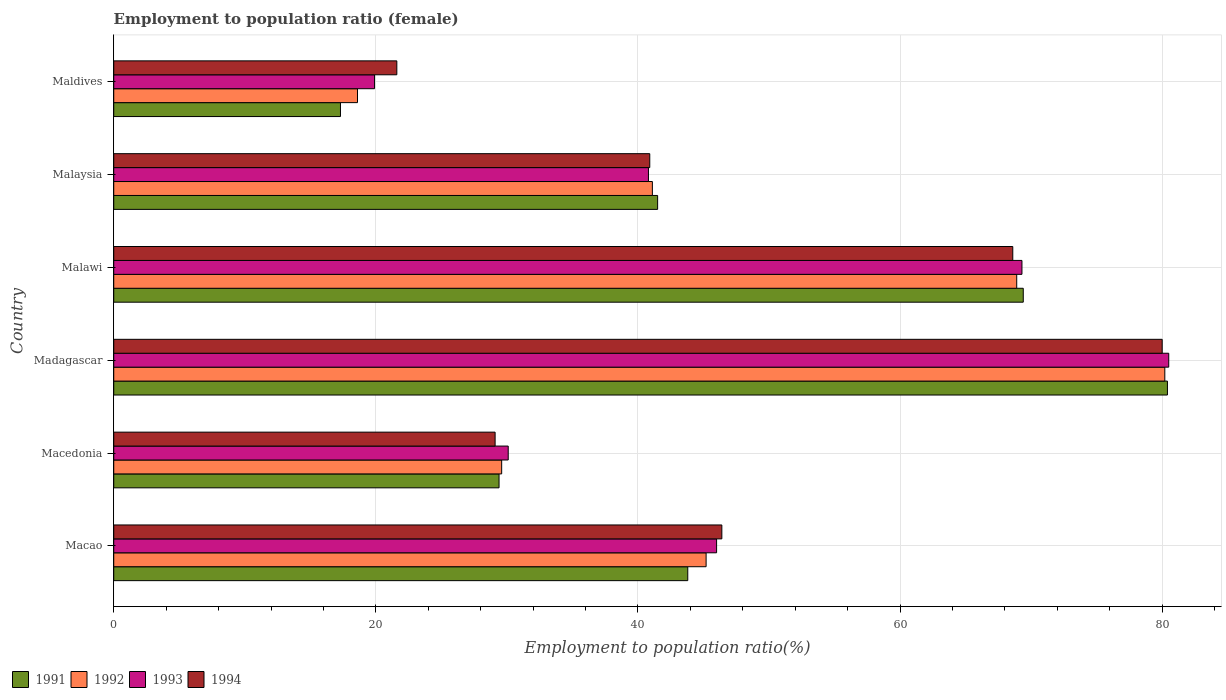How many groups of bars are there?
Your answer should be very brief. 6. Are the number of bars on each tick of the Y-axis equal?
Your answer should be compact. Yes. How many bars are there on the 2nd tick from the top?
Your answer should be very brief. 4. What is the label of the 5th group of bars from the top?
Your answer should be compact. Macedonia. What is the employment to population ratio in 1991 in Macao?
Offer a terse response. 43.8. Across all countries, what is the maximum employment to population ratio in 1994?
Offer a terse response. 80. Across all countries, what is the minimum employment to population ratio in 1993?
Your response must be concise. 19.9. In which country was the employment to population ratio in 1993 maximum?
Make the answer very short. Madagascar. In which country was the employment to population ratio in 1993 minimum?
Give a very brief answer. Maldives. What is the total employment to population ratio in 1994 in the graph?
Give a very brief answer. 286.6. What is the difference between the employment to population ratio in 1991 in Macao and that in Macedonia?
Make the answer very short. 14.4. What is the difference between the employment to population ratio in 1993 in Malawi and the employment to population ratio in 1994 in Madagascar?
Your answer should be compact. -10.7. What is the average employment to population ratio in 1994 per country?
Your answer should be compact. 47.77. What is the difference between the employment to population ratio in 1993 and employment to population ratio in 1992 in Maldives?
Provide a short and direct response. 1.3. What is the ratio of the employment to population ratio in 1993 in Madagascar to that in Maldives?
Offer a very short reply. 4.05. Is the employment to population ratio in 1992 in Macao less than that in Malawi?
Make the answer very short. Yes. Is the difference between the employment to population ratio in 1993 in Macao and Macedonia greater than the difference between the employment to population ratio in 1992 in Macao and Macedonia?
Provide a short and direct response. Yes. What is the difference between the highest and the second highest employment to population ratio in 1994?
Make the answer very short. 11.4. What is the difference between the highest and the lowest employment to population ratio in 1993?
Keep it short and to the point. 60.6. In how many countries, is the employment to population ratio in 1991 greater than the average employment to population ratio in 1991 taken over all countries?
Give a very brief answer. 2. Is it the case that in every country, the sum of the employment to population ratio in 1992 and employment to population ratio in 1994 is greater than the sum of employment to population ratio in 1991 and employment to population ratio in 1993?
Your answer should be compact. No. What does the 4th bar from the bottom in Malawi represents?
Make the answer very short. 1994. How many countries are there in the graph?
Offer a very short reply. 6. What is the difference between two consecutive major ticks on the X-axis?
Give a very brief answer. 20. Are the values on the major ticks of X-axis written in scientific E-notation?
Your answer should be very brief. No. Does the graph contain any zero values?
Provide a short and direct response. No. How many legend labels are there?
Your answer should be very brief. 4. What is the title of the graph?
Your response must be concise. Employment to population ratio (female). Does "2012" appear as one of the legend labels in the graph?
Offer a terse response. No. What is the label or title of the X-axis?
Offer a very short reply. Employment to population ratio(%). What is the Employment to population ratio(%) of 1991 in Macao?
Give a very brief answer. 43.8. What is the Employment to population ratio(%) of 1992 in Macao?
Provide a succinct answer. 45.2. What is the Employment to population ratio(%) in 1994 in Macao?
Provide a short and direct response. 46.4. What is the Employment to population ratio(%) of 1991 in Macedonia?
Keep it short and to the point. 29.4. What is the Employment to population ratio(%) in 1992 in Macedonia?
Your answer should be very brief. 29.6. What is the Employment to population ratio(%) of 1993 in Macedonia?
Make the answer very short. 30.1. What is the Employment to population ratio(%) in 1994 in Macedonia?
Your answer should be very brief. 29.1. What is the Employment to population ratio(%) in 1991 in Madagascar?
Your answer should be compact. 80.4. What is the Employment to population ratio(%) in 1992 in Madagascar?
Offer a very short reply. 80.2. What is the Employment to population ratio(%) of 1993 in Madagascar?
Your response must be concise. 80.5. What is the Employment to population ratio(%) in 1994 in Madagascar?
Your response must be concise. 80. What is the Employment to population ratio(%) of 1991 in Malawi?
Offer a terse response. 69.4. What is the Employment to population ratio(%) of 1992 in Malawi?
Your answer should be very brief. 68.9. What is the Employment to population ratio(%) of 1993 in Malawi?
Provide a short and direct response. 69.3. What is the Employment to population ratio(%) of 1994 in Malawi?
Offer a terse response. 68.6. What is the Employment to population ratio(%) in 1991 in Malaysia?
Offer a terse response. 41.5. What is the Employment to population ratio(%) of 1992 in Malaysia?
Make the answer very short. 41.1. What is the Employment to population ratio(%) in 1993 in Malaysia?
Provide a succinct answer. 40.8. What is the Employment to population ratio(%) of 1994 in Malaysia?
Provide a short and direct response. 40.9. What is the Employment to population ratio(%) in 1991 in Maldives?
Provide a short and direct response. 17.3. What is the Employment to population ratio(%) of 1992 in Maldives?
Provide a succinct answer. 18.6. What is the Employment to population ratio(%) of 1993 in Maldives?
Offer a terse response. 19.9. What is the Employment to population ratio(%) of 1994 in Maldives?
Offer a terse response. 21.6. Across all countries, what is the maximum Employment to population ratio(%) in 1991?
Your answer should be compact. 80.4. Across all countries, what is the maximum Employment to population ratio(%) in 1992?
Your response must be concise. 80.2. Across all countries, what is the maximum Employment to population ratio(%) in 1993?
Your answer should be compact. 80.5. Across all countries, what is the minimum Employment to population ratio(%) of 1991?
Offer a very short reply. 17.3. Across all countries, what is the minimum Employment to population ratio(%) in 1992?
Offer a very short reply. 18.6. Across all countries, what is the minimum Employment to population ratio(%) in 1993?
Your answer should be compact. 19.9. Across all countries, what is the minimum Employment to population ratio(%) of 1994?
Give a very brief answer. 21.6. What is the total Employment to population ratio(%) in 1991 in the graph?
Ensure brevity in your answer.  281.8. What is the total Employment to population ratio(%) in 1992 in the graph?
Provide a short and direct response. 283.6. What is the total Employment to population ratio(%) of 1993 in the graph?
Ensure brevity in your answer.  286.6. What is the total Employment to population ratio(%) of 1994 in the graph?
Keep it short and to the point. 286.6. What is the difference between the Employment to population ratio(%) in 1992 in Macao and that in Macedonia?
Provide a succinct answer. 15.6. What is the difference between the Employment to population ratio(%) of 1993 in Macao and that in Macedonia?
Your response must be concise. 15.9. What is the difference between the Employment to population ratio(%) in 1991 in Macao and that in Madagascar?
Ensure brevity in your answer.  -36.6. What is the difference between the Employment to population ratio(%) of 1992 in Macao and that in Madagascar?
Provide a succinct answer. -35. What is the difference between the Employment to population ratio(%) of 1993 in Macao and that in Madagascar?
Your response must be concise. -34.5. What is the difference between the Employment to population ratio(%) in 1994 in Macao and that in Madagascar?
Provide a short and direct response. -33.6. What is the difference between the Employment to population ratio(%) in 1991 in Macao and that in Malawi?
Your answer should be compact. -25.6. What is the difference between the Employment to population ratio(%) of 1992 in Macao and that in Malawi?
Keep it short and to the point. -23.7. What is the difference between the Employment to population ratio(%) in 1993 in Macao and that in Malawi?
Your response must be concise. -23.3. What is the difference between the Employment to population ratio(%) of 1994 in Macao and that in Malawi?
Your answer should be very brief. -22.2. What is the difference between the Employment to population ratio(%) of 1991 in Macao and that in Malaysia?
Offer a very short reply. 2.3. What is the difference between the Employment to population ratio(%) in 1992 in Macao and that in Maldives?
Your answer should be compact. 26.6. What is the difference between the Employment to population ratio(%) in 1993 in Macao and that in Maldives?
Give a very brief answer. 26.1. What is the difference between the Employment to population ratio(%) in 1994 in Macao and that in Maldives?
Your response must be concise. 24.8. What is the difference between the Employment to population ratio(%) in 1991 in Macedonia and that in Madagascar?
Offer a very short reply. -51. What is the difference between the Employment to population ratio(%) in 1992 in Macedonia and that in Madagascar?
Your answer should be compact. -50.6. What is the difference between the Employment to population ratio(%) in 1993 in Macedonia and that in Madagascar?
Provide a succinct answer. -50.4. What is the difference between the Employment to population ratio(%) in 1994 in Macedonia and that in Madagascar?
Provide a succinct answer. -50.9. What is the difference between the Employment to population ratio(%) in 1991 in Macedonia and that in Malawi?
Offer a very short reply. -40. What is the difference between the Employment to population ratio(%) in 1992 in Macedonia and that in Malawi?
Offer a very short reply. -39.3. What is the difference between the Employment to population ratio(%) of 1993 in Macedonia and that in Malawi?
Your answer should be very brief. -39.2. What is the difference between the Employment to population ratio(%) of 1994 in Macedonia and that in Malawi?
Provide a short and direct response. -39.5. What is the difference between the Employment to population ratio(%) in 1991 in Macedonia and that in Malaysia?
Your answer should be compact. -12.1. What is the difference between the Employment to population ratio(%) of 1992 in Macedonia and that in Malaysia?
Your response must be concise. -11.5. What is the difference between the Employment to population ratio(%) of 1993 in Macedonia and that in Malaysia?
Your response must be concise. -10.7. What is the difference between the Employment to population ratio(%) of 1992 in Macedonia and that in Maldives?
Your answer should be very brief. 11. What is the difference between the Employment to population ratio(%) of 1993 in Macedonia and that in Maldives?
Provide a short and direct response. 10.2. What is the difference between the Employment to population ratio(%) of 1991 in Madagascar and that in Malawi?
Keep it short and to the point. 11. What is the difference between the Employment to population ratio(%) of 1992 in Madagascar and that in Malawi?
Keep it short and to the point. 11.3. What is the difference between the Employment to population ratio(%) in 1993 in Madagascar and that in Malawi?
Your answer should be very brief. 11.2. What is the difference between the Employment to population ratio(%) of 1991 in Madagascar and that in Malaysia?
Make the answer very short. 38.9. What is the difference between the Employment to population ratio(%) of 1992 in Madagascar and that in Malaysia?
Give a very brief answer. 39.1. What is the difference between the Employment to population ratio(%) of 1993 in Madagascar and that in Malaysia?
Your response must be concise. 39.7. What is the difference between the Employment to population ratio(%) in 1994 in Madagascar and that in Malaysia?
Ensure brevity in your answer.  39.1. What is the difference between the Employment to population ratio(%) of 1991 in Madagascar and that in Maldives?
Ensure brevity in your answer.  63.1. What is the difference between the Employment to population ratio(%) of 1992 in Madagascar and that in Maldives?
Ensure brevity in your answer.  61.6. What is the difference between the Employment to population ratio(%) of 1993 in Madagascar and that in Maldives?
Your answer should be compact. 60.6. What is the difference between the Employment to population ratio(%) in 1994 in Madagascar and that in Maldives?
Offer a terse response. 58.4. What is the difference between the Employment to population ratio(%) of 1991 in Malawi and that in Malaysia?
Ensure brevity in your answer.  27.9. What is the difference between the Employment to population ratio(%) in 1992 in Malawi and that in Malaysia?
Your answer should be compact. 27.8. What is the difference between the Employment to population ratio(%) of 1993 in Malawi and that in Malaysia?
Give a very brief answer. 28.5. What is the difference between the Employment to population ratio(%) of 1994 in Malawi and that in Malaysia?
Offer a very short reply. 27.7. What is the difference between the Employment to population ratio(%) of 1991 in Malawi and that in Maldives?
Offer a terse response. 52.1. What is the difference between the Employment to population ratio(%) in 1992 in Malawi and that in Maldives?
Your answer should be compact. 50.3. What is the difference between the Employment to population ratio(%) of 1993 in Malawi and that in Maldives?
Give a very brief answer. 49.4. What is the difference between the Employment to population ratio(%) of 1991 in Malaysia and that in Maldives?
Your response must be concise. 24.2. What is the difference between the Employment to population ratio(%) in 1993 in Malaysia and that in Maldives?
Your answer should be very brief. 20.9. What is the difference between the Employment to population ratio(%) of 1994 in Malaysia and that in Maldives?
Ensure brevity in your answer.  19.3. What is the difference between the Employment to population ratio(%) in 1991 in Macao and the Employment to population ratio(%) in 1993 in Macedonia?
Offer a terse response. 13.7. What is the difference between the Employment to population ratio(%) of 1992 in Macao and the Employment to population ratio(%) of 1994 in Macedonia?
Your response must be concise. 16.1. What is the difference between the Employment to population ratio(%) in 1991 in Macao and the Employment to population ratio(%) in 1992 in Madagascar?
Provide a succinct answer. -36.4. What is the difference between the Employment to population ratio(%) of 1991 in Macao and the Employment to population ratio(%) of 1993 in Madagascar?
Offer a terse response. -36.7. What is the difference between the Employment to population ratio(%) in 1991 in Macao and the Employment to population ratio(%) in 1994 in Madagascar?
Make the answer very short. -36.2. What is the difference between the Employment to population ratio(%) of 1992 in Macao and the Employment to population ratio(%) of 1993 in Madagascar?
Offer a terse response. -35.3. What is the difference between the Employment to population ratio(%) in 1992 in Macao and the Employment to population ratio(%) in 1994 in Madagascar?
Your response must be concise. -34.8. What is the difference between the Employment to population ratio(%) of 1993 in Macao and the Employment to population ratio(%) of 1994 in Madagascar?
Make the answer very short. -34. What is the difference between the Employment to population ratio(%) of 1991 in Macao and the Employment to population ratio(%) of 1992 in Malawi?
Your response must be concise. -25.1. What is the difference between the Employment to population ratio(%) in 1991 in Macao and the Employment to population ratio(%) in 1993 in Malawi?
Make the answer very short. -25.5. What is the difference between the Employment to population ratio(%) in 1991 in Macao and the Employment to population ratio(%) in 1994 in Malawi?
Offer a terse response. -24.8. What is the difference between the Employment to population ratio(%) of 1992 in Macao and the Employment to population ratio(%) of 1993 in Malawi?
Make the answer very short. -24.1. What is the difference between the Employment to population ratio(%) of 1992 in Macao and the Employment to population ratio(%) of 1994 in Malawi?
Offer a very short reply. -23.4. What is the difference between the Employment to population ratio(%) in 1993 in Macao and the Employment to population ratio(%) in 1994 in Malawi?
Your answer should be compact. -22.6. What is the difference between the Employment to population ratio(%) of 1991 in Macao and the Employment to population ratio(%) of 1992 in Malaysia?
Ensure brevity in your answer.  2.7. What is the difference between the Employment to population ratio(%) in 1992 in Macao and the Employment to population ratio(%) in 1994 in Malaysia?
Make the answer very short. 4.3. What is the difference between the Employment to population ratio(%) of 1991 in Macao and the Employment to population ratio(%) of 1992 in Maldives?
Your answer should be compact. 25.2. What is the difference between the Employment to population ratio(%) of 1991 in Macao and the Employment to population ratio(%) of 1993 in Maldives?
Make the answer very short. 23.9. What is the difference between the Employment to population ratio(%) in 1991 in Macao and the Employment to population ratio(%) in 1994 in Maldives?
Keep it short and to the point. 22.2. What is the difference between the Employment to population ratio(%) in 1992 in Macao and the Employment to population ratio(%) in 1993 in Maldives?
Offer a terse response. 25.3. What is the difference between the Employment to population ratio(%) of 1992 in Macao and the Employment to population ratio(%) of 1994 in Maldives?
Your response must be concise. 23.6. What is the difference between the Employment to population ratio(%) in 1993 in Macao and the Employment to population ratio(%) in 1994 in Maldives?
Ensure brevity in your answer.  24.4. What is the difference between the Employment to population ratio(%) of 1991 in Macedonia and the Employment to population ratio(%) of 1992 in Madagascar?
Provide a succinct answer. -50.8. What is the difference between the Employment to population ratio(%) of 1991 in Macedonia and the Employment to population ratio(%) of 1993 in Madagascar?
Provide a short and direct response. -51.1. What is the difference between the Employment to population ratio(%) in 1991 in Macedonia and the Employment to population ratio(%) in 1994 in Madagascar?
Your answer should be compact. -50.6. What is the difference between the Employment to population ratio(%) of 1992 in Macedonia and the Employment to population ratio(%) of 1993 in Madagascar?
Ensure brevity in your answer.  -50.9. What is the difference between the Employment to population ratio(%) in 1992 in Macedonia and the Employment to population ratio(%) in 1994 in Madagascar?
Offer a terse response. -50.4. What is the difference between the Employment to population ratio(%) in 1993 in Macedonia and the Employment to population ratio(%) in 1994 in Madagascar?
Your answer should be very brief. -49.9. What is the difference between the Employment to population ratio(%) of 1991 in Macedonia and the Employment to population ratio(%) of 1992 in Malawi?
Offer a very short reply. -39.5. What is the difference between the Employment to population ratio(%) in 1991 in Macedonia and the Employment to population ratio(%) in 1993 in Malawi?
Provide a succinct answer. -39.9. What is the difference between the Employment to population ratio(%) of 1991 in Macedonia and the Employment to population ratio(%) of 1994 in Malawi?
Provide a short and direct response. -39.2. What is the difference between the Employment to population ratio(%) of 1992 in Macedonia and the Employment to population ratio(%) of 1993 in Malawi?
Keep it short and to the point. -39.7. What is the difference between the Employment to population ratio(%) of 1992 in Macedonia and the Employment to population ratio(%) of 1994 in Malawi?
Provide a succinct answer. -39. What is the difference between the Employment to population ratio(%) of 1993 in Macedonia and the Employment to population ratio(%) of 1994 in Malawi?
Give a very brief answer. -38.5. What is the difference between the Employment to population ratio(%) in 1991 in Macedonia and the Employment to population ratio(%) in 1992 in Malaysia?
Your response must be concise. -11.7. What is the difference between the Employment to population ratio(%) of 1991 in Macedonia and the Employment to population ratio(%) of 1993 in Malaysia?
Offer a terse response. -11.4. What is the difference between the Employment to population ratio(%) in 1992 in Macedonia and the Employment to population ratio(%) in 1994 in Malaysia?
Your response must be concise. -11.3. What is the difference between the Employment to population ratio(%) of 1991 in Macedonia and the Employment to population ratio(%) of 1992 in Maldives?
Make the answer very short. 10.8. What is the difference between the Employment to population ratio(%) of 1992 in Macedonia and the Employment to population ratio(%) of 1993 in Maldives?
Provide a short and direct response. 9.7. What is the difference between the Employment to population ratio(%) in 1992 in Macedonia and the Employment to population ratio(%) in 1994 in Maldives?
Offer a very short reply. 8. What is the difference between the Employment to population ratio(%) of 1991 in Madagascar and the Employment to population ratio(%) of 1994 in Malawi?
Your answer should be very brief. 11.8. What is the difference between the Employment to population ratio(%) in 1992 in Madagascar and the Employment to population ratio(%) in 1994 in Malawi?
Offer a very short reply. 11.6. What is the difference between the Employment to population ratio(%) of 1991 in Madagascar and the Employment to population ratio(%) of 1992 in Malaysia?
Provide a short and direct response. 39.3. What is the difference between the Employment to population ratio(%) of 1991 in Madagascar and the Employment to population ratio(%) of 1993 in Malaysia?
Provide a succinct answer. 39.6. What is the difference between the Employment to population ratio(%) of 1991 in Madagascar and the Employment to population ratio(%) of 1994 in Malaysia?
Provide a short and direct response. 39.5. What is the difference between the Employment to population ratio(%) of 1992 in Madagascar and the Employment to population ratio(%) of 1993 in Malaysia?
Provide a short and direct response. 39.4. What is the difference between the Employment to population ratio(%) of 1992 in Madagascar and the Employment to population ratio(%) of 1994 in Malaysia?
Give a very brief answer. 39.3. What is the difference between the Employment to population ratio(%) of 1993 in Madagascar and the Employment to population ratio(%) of 1994 in Malaysia?
Your answer should be very brief. 39.6. What is the difference between the Employment to population ratio(%) in 1991 in Madagascar and the Employment to population ratio(%) in 1992 in Maldives?
Provide a succinct answer. 61.8. What is the difference between the Employment to population ratio(%) of 1991 in Madagascar and the Employment to population ratio(%) of 1993 in Maldives?
Offer a terse response. 60.5. What is the difference between the Employment to population ratio(%) of 1991 in Madagascar and the Employment to population ratio(%) of 1994 in Maldives?
Offer a terse response. 58.8. What is the difference between the Employment to population ratio(%) of 1992 in Madagascar and the Employment to population ratio(%) of 1993 in Maldives?
Offer a very short reply. 60.3. What is the difference between the Employment to population ratio(%) of 1992 in Madagascar and the Employment to population ratio(%) of 1994 in Maldives?
Keep it short and to the point. 58.6. What is the difference between the Employment to population ratio(%) in 1993 in Madagascar and the Employment to population ratio(%) in 1994 in Maldives?
Provide a succinct answer. 58.9. What is the difference between the Employment to population ratio(%) of 1991 in Malawi and the Employment to population ratio(%) of 1992 in Malaysia?
Offer a very short reply. 28.3. What is the difference between the Employment to population ratio(%) in 1991 in Malawi and the Employment to population ratio(%) in 1993 in Malaysia?
Your response must be concise. 28.6. What is the difference between the Employment to population ratio(%) in 1992 in Malawi and the Employment to population ratio(%) in 1993 in Malaysia?
Give a very brief answer. 28.1. What is the difference between the Employment to population ratio(%) of 1992 in Malawi and the Employment to population ratio(%) of 1994 in Malaysia?
Your answer should be very brief. 28. What is the difference between the Employment to population ratio(%) in 1993 in Malawi and the Employment to population ratio(%) in 1994 in Malaysia?
Provide a short and direct response. 28.4. What is the difference between the Employment to population ratio(%) of 1991 in Malawi and the Employment to population ratio(%) of 1992 in Maldives?
Ensure brevity in your answer.  50.8. What is the difference between the Employment to population ratio(%) of 1991 in Malawi and the Employment to population ratio(%) of 1993 in Maldives?
Keep it short and to the point. 49.5. What is the difference between the Employment to population ratio(%) of 1991 in Malawi and the Employment to population ratio(%) of 1994 in Maldives?
Offer a very short reply. 47.8. What is the difference between the Employment to population ratio(%) of 1992 in Malawi and the Employment to population ratio(%) of 1994 in Maldives?
Give a very brief answer. 47.3. What is the difference between the Employment to population ratio(%) in 1993 in Malawi and the Employment to population ratio(%) in 1994 in Maldives?
Offer a terse response. 47.7. What is the difference between the Employment to population ratio(%) of 1991 in Malaysia and the Employment to population ratio(%) of 1992 in Maldives?
Your response must be concise. 22.9. What is the difference between the Employment to population ratio(%) in 1991 in Malaysia and the Employment to population ratio(%) in 1993 in Maldives?
Keep it short and to the point. 21.6. What is the difference between the Employment to population ratio(%) in 1992 in Malaysia and the Employment to population ratio(%) in 1993 in Maldives?
Keep it short and to the point. 21.2. What is the difference between the Employment to population ratio(%) in 1992 in Malaysia and the Employment to population ratio(%) in 1994 in Maldives?
Ensure brevity in your answer.  19.5. What is the difference between the Employment to population ratio(%) of 1993 in Malaysia and the Employment to population ratio(%) of 1994 in Maldives?
Make the answer very short. 19.2. What is the average Employment to population ratio(%) in 1991 per country?
Ensure brevity in your answer.  46.97. What is the average Employment to population ratio(%) in 1992 per country?
Offer a terse response. 47.27. What is the average Employment to population ratio(%) of 1993 per country?
Offer a very short reply. 47.77. What is the average Employment to population ratio(%) of 1994 per country?
Offer a very short reply. 47.77. What is the difference between the Employment to population ratio(%) in 1992 and Employment to population ratio(%) in 1993 in Macao?
Offer a terse response. -0.8. What is the difference between the Employment to population ratio(%) in 1992 and Employment to population ratio(%) in 1994 in Macao?
Make the answer very short. -1.2. What is the difference between the Employment to population ratio(%) in 1993 and Employment to population ratio(%) in 1994 in Macao?
Ensure brevity in your answer.  -0.4. What is the difference between the Employment to population ratio(%) in 1991 and Employment to population ratio(%) in 1992 in Macedonia?
Provide a succinct answer. -0.2. What is the difference between the Employment to population ratio(%) in 1991 and Employment to population ratio(%) in 1993 in Macedonia?
Offer a terse response. -0.7. What is the difference between the Employment to population ratio(%) of 1992 and Employment to population ratio(%) of 1993 in Macedonia?
Your response must be concise. -0.5. What is the difference between the Employment to population ratio(%) of 1992 and Employment to population ratio(%) of 1994 in Macedonia?
Provide a short and direct response. 0.5. What is the difference between the Employment to population ratio(%) in 1992 and Employment to population ratio(%) in 1993 in Madagascar?
Provide a succinct answer. -0.3. What is the difference between the Employment to population ratio(%) in 1992 and Employment to population ratio(%) in 1994 in Madagascar?
Make the answer very short. 0.2. What is the difference between the Employment to population ratio(%) of 1993 and Employment to population ratio(%) of 1994 in Madagascar?
Give a very brief answer. 0.5. What is the difference between the Employment to population ratio(%) in 1992 and Employment to population ratio(%) in 1993 in Malawi?
Give a very brief answer. -0.4. What is the difference between the Employment to population ratio(%) of 1992 and Employment to population ratio(%) of 1994 in Malawi?
Keep it short and to the point. 0.3. What is the difference between the Employment to population ratio(%) in 1993 and Employment to population ratio(%) in 1994 in Malawi?
Your response must be concise. 0.7. What is the difference between the Employment to population ratio(%) of 1992 and Employment to population ratio(%) of 1993 in Malaysia?
Provide a short and direct response. 0.3. What is the difference between the Employment to population ratio(%) in 1991 and Employment to population ratio(%) in 1993 in Maldives?
Offer a terse response. -2.6. What is the difference between the Employment to population ratio(%) in 1991 and Employment to population ratio(%) in 1994 in Maldives?
Keep it short and to the point. -4.3. What is the difference between the Employment to population ratio(%) of 1992 and Employment to population ratio(%) of 1994 in Maldives?
Your answer should be very brief. -3. What is the difference between the Employment to population ratio(%) of 1993 and Employment to population ratio(%) of 1994 in Maldives?
Give a very brief answer. -1.7. What is the ratio of the Employment to population ratio(%) in 1991 in Macao to that in Macedonia?
Keep it short and to the point. 1.49. What is the ratio of the Employment to population ratio(%) in 1992 in Macao to that in Macedonia?
Offer a very short reply. 1.53. What is the ratio of the Employment to population ratio(%) of 1993 in Macao to that in Macedonia?
Offer a terse response. 1.53. What is the ratio of the Employment to population ratio(%) of 1994 in Macao to that in Macedonia?
Provide a short and direct response. 1.59. What is the ratio of the Employment to population ratio(%) of 1991 in Macao to that in Madagascar?
Provide a short and direct response. 0.54. What is the ratio of the Employment to population ratio(%) of 1992 in Macao to that in Madagascar?
Give a very brief answer. 0.56. What is the ratio of the Employment to population ratio(%) of 1993 in Macao to that in Madagascar?
Offer a terse response. 0.57. What is the ratio of the Employment to population ratio(%) in 1994 in Macao to that in Madagascar?
Provide a short and direct response. 0.58. What is the ratio of the Employment to population ratio(%) of 1991 in Macao to that in Malawi?
Provide a succinct answer. 0.63. What is the ratio of the Employment to population ratio(%) of 1992 in Macao to that in Malawi?
Offer a terse response. 0.66. What is the ratio of the Employment to population ratio(%) of 1993 in Macao to that in Malawi?
Provide a succinct answer. 0.66. What is the ratio of the Employment to population ratio(%) of 1994 in Macao to that in Malawi?
Your response must be concise. 0.68. What is the ratio of the Employment to population ratio(%) of 1991 in Macao to that in Malaysia?
Offer a terse response. 1.06. What is the ratio of the Employment to population ratio(%) of 1992 in Macao to that in Malaysia?
Ensure brevity in your answer.  1.1. What is the ratio of the Employment to population ratio(%) of 1993 in Macao to that in Malaysia?
Offer a very short reply. 1.13. What is the ratio of the Employment to population ratio(%) in 1994 in Macao to that in Malaysia?
Ensure brevity in your answer.  1.13. What is the ratio of the Employment to population ratio(%) of 1991 in Macao to that in Maldives?
Your answer should be compact. 2.53. What is the ratio of the Employment to population ratio(%) in 1992 in Macao to that in Maldives?
Your answer should be compact. 2.43. What is the ratio of the Employment to population ratio(%) in 1993 in Macao to that in Maldives?
Provide a succinct answer. 2.31. What is the ratio of the Employment to population ratio(%) of 1994 in Macao to that in Maldives?
Provide a short and direct response. 2.15. What is the ratio of the Employment to population ratio(%) in 1991 in Macedonia to that in Madagascar?
Offer a very short reply. 0.37. What is the ratio of the Employment to population ratio(%) in 1992 in Macedonia to that in Madagascar?
Keep it short and to the point. 0.37. What is the ratio of the Employment to population ratio(%) of 1993 in Macedonia to that in Madagascar?
Provide a succinct answer. 0.37. What is the ratio of the Employment to population ratio(%) of 1994 in Macedonia to that in Madagascar?
Your answer should be compact. 0.36. What is the ratio of the Employment to population ratio(%) in 1991 in Macedonia to that in Malawi?
Give a very brief answer. 0.42. What is the ratio of the Employment to population ratio(%) in 1992 in Macedonia to that in Malawi?
Make the answer very short. 0.43. What is the ratio of the Employment to population ratio(%) of 1993 in Macedonia to that in Malawi?
Your answer should be compact. 0.43. What is the ratio of the Employment to population ratio(%) of 1994 in Macedonia to that in Malawi?
Provide a short and direct response. 0.42. What is the ratio of the Employment to population ratio(%) of 1991 in Macedonia to that in Malaysia?
Make the answer very short. 0.71. What is the ratio of the Employment to population ratio(%) of 1992 in Macedonia to that in Malaysia?
Keep it short and to the point. 0.72. What is the ratio of the Employment to population ratio(%) of 1993 in Macedonia to that in Malaysia?
Keep it short and to the point. 0.74. What is the ratio of the Employment to population ratio(%) of 1994 in Macedonia to that in Malaysia?
Your answer should be very brief. 0.71. What is the ratio of the Employment to population ratio(%) in 1991 in Macedonia to that in Maldives?
Keep it short and to the point. 1.7. What is the ratio of the Employment to population ratio(%) of 1992 in Macedonia to that in Maldives?
Offer a terse response. 1.59. What is the ratio of the Employment to population ratio(%) in 1993 in Macedonia to that in Maldives?
Make the answer very short. 1.51. What is the ratio of the Employment to population ratio(%) of 1994 in Macedonia to that in Maldives?
Provide a short and direct response. 1.35. What is the ratio of the Employment to population ratio(%) of 1991 in Madagascar to that in Malawi?
Your response must be concise. 1.16. What is the ratio of the Employment to population ratio(%) of 1992 in Madagascar to that in Malawi?
Offer a terse response. 1.16. What is the ratio of the Employment to population ratio(%) in 1993 in Madagascar to that in Malawi?
Your answer should be very brief. 1.16. What is the ratio of the Employment to population ratio(%) in 1994 in Madagascar to that in Malawi?
Keep it short and to the point. 1.17. What is the ratio of the Employment to population ratio(%) of 1991 in Madagascar to that in Malaysia?
Provide a succinct answer. 1.94. What is the ratio of the Employment to population ratio(%) in 1992 in Madagascar to that in Malaysia?
Give a very brief answer. 1.95. What is the ratio of the Employment to population ratio(%) of 1993 in Madagascar to that in Malaysia?
Offer a terse response. 1.97. What is the ratio of the Employment to population ratio(%) in 1994 in Madagascar to that in Malaysia?
Your answer should be compact. 1.96. What is the ratio of the Employment to population ratio(%) of 1991 in Madagascar to that in Maldives?
Provide a short and direct response. 4.65. What is the ratio of the Employment to population ratio(%) in 1992 in Madagascar to that in Maldives?
Your answer should be compact. 4.31. What is the ratio of the Employment to population ratio(%) in 1993 in Madagascar to that in Maldives?
Your answer should be compact. 4.05. What is the ratio of the Employment to population ratio(%) in 1994 in Madagascar to that in Maldives?
Your answer should be compact. 3.7. What is the ratio of the Employment to population ratio(%) of 1991 in Malawi to that in Malaysia?
Keep it short and to the point. 1.67. What is the ratio of the Employment to population ratio(%) in 1992 in Malawi to that in Malaysia?
Give a very brief answer. 1.68. What is the ratio of the Employment to population ratio(%) of 1993 in Malawi to that in Malaysia?
Offer a terse response. 1.7. What is the ratio of the Employment to population ratio(%) in 1994 in Malawi to that in Malaysia?
Offer a terse response. 1.68. What is the ratio of the Employment to population ratio(%) in 1991 in Malawi to that in Maldives?
Keep it short and to the point. 4.01. What is the ratio of the Employment to population ratio(%) of 1992 in Malawi to that in Maldives?
Your answer should be compact. 3.7. What is the ratio of the Employment to population ratio(%) in 1993 in Malawi to that in Maldives?
Offer a very short reply. 3.48. What is the ratio of the Employment to population ratio(%) in 1994 in Malawi to that in Maldives?
Your answer should be very brief. 3.18. What is the ratio of the Employment to population ratio(%) in 1991 in Malaysia to that in Maldives?
Provide a short and direct response. 2.4. What is the ratio of the Employment to population ratio(%) of 1992 in Malaysia to that in Maldives?
Ensure brevity in your answer.  2.21. What is the ratio of the Employment to population ratio(%) in 1993 in Malaysia to that in Maldives?
Offer a very short reply. 2.05. What is the ratio of the Employment to population ratio(%) in 1994 in Malaysia to that in Maldives?
Make the answer very short. 1.89. What is the difference between the highest and the second highest Employment to population ratio(%) of 1993?
Your answer should be very brief. 11.2. What is the difference between the highest and the second highest Employment to population ratio(%) in 1994?
Provide a short and direct response. 11.4. What is the difference between the highest and the lowest Employment to population ratio(%) of 1991?
Your response must be concise. 63.1. What is the difference between the highest and the lowest Employment to population ratio(%) in 1992?
Offer a very short reply. 61.6. What is the difference between the highest and the lowest Employment to population ratio(%) in 1993?
Offer a terse response. 60.6. What is the difference between the highest and the lowest Employment to population ratio(%) of 1994?
Provide a succinct answer. 58.4. 